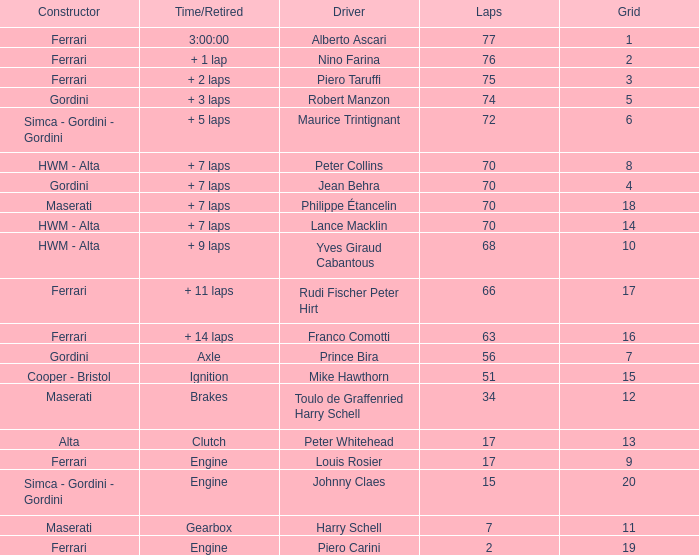How many grids for peter collins? 1.0. 